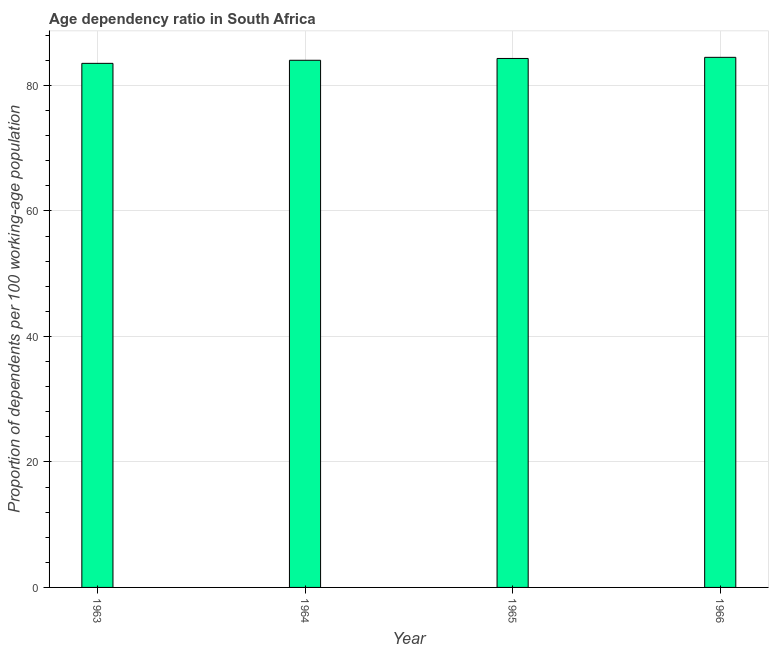Does the graph contain grids?
Provide a short and direct response. Yes. What is the title of the graph?
Ensure brevity in your answer.  Age dependency ratio in South Africa. What is the label or title of the X-axis?
Your response must be concise. Year. What is the label or title of the Y-axis?
Your answer should be very brief. Proportion of dependents per 100 working-age population. What is the age dependency ratio in 1963?
Give a very brief answer. 83.53. Across all years, what is the maximum age dependency ratio?
Provide a succinct answer. 84.49. Across all years, what is the minimum age dependency ratio?
Give a very brief answer. 83.53. In which year was the age dependency ratio maximum?
Provide a short and direct response. 1966. What is the sum of the age dependency ratio?
Offer a very short reply. 336.35. What is the difference between the age dependency ratio in 1964 and 1965?
Make the answer very short. -0.29. What is the average age dependency ratio per year?
Offer a terse response. 84.09. What is the median age dependency ratio?
Give a very brief answer. 84.17. What is the difference between the highest and the second highest age dependency ratio?
Make the answer very short. 0.18. Is the sum of the age dependency ratio in 1964 and 1965 greater than the maximum age dependency ratio across all years?
Your response must be concise. Yes. What is the difference between the highest and the lowest age dependency ratio?
Your answer should be compact. 0.96. In how many years, is the age dependency ratio greater than the average age dependency ratio taken over all years?
Ensure brevity in your answer.  2. How many years are there in the graph?
Give a very brief answer. 4. What is the difference between two consecutive major ticks on the Y-axis?
Provide a succinct answer. 20. Are the values on the major ticks of Y-axis written in scientific E-notation?
Your answer should be very brief. No. What is the Proportion of dependents per 100 working-age population in 1963?
Offer a terse response. 83.53. What is the Proportion of dependents per 100 working-age population of 1964?
Provide a succinct answer. 84.02. What is the Proportion of dependents per 100 working-age population of 1965?
Offer a terse response. 84.31. What is the Proportion of dependents per 100 working-age population in 1966?
Give a very brief answer. 84.49. What is the difference between the Proportion of dependents per 100 working-age population in 1963 and 1964?
Give a very brief answer. -0.49. What is the difference between the Proportion of dependents per 100 working-age population in 1963 and 1965?
Provide a short and direct response. -0.78. What is the difference between the Proportion of dependents per 100 working-age population in 1963 and 1966?
Keep it short and to the point. -0.96. What is the difference between the Proportion of dependents per 100 working-age population in 1964 and 1965?
Provide a succinct answer. -0.29. What is the difference between the Proportion of dependents per 100 working-age population in 1964 and 1966?
Offer a terse response. -0.47. What is the difference between the Proportion of dependents per 100 working-age population in 1965 and 1966?
Provide a short and direct response. -0.18. What is the ratio of the Proportion of dependents per 100 working-age population in 1963 to that in 1965?
Your answer should be very brief. 0.99. What is the ratio of the Proportion of dependents per 100 working-age population in 1963 to that in 1966?
Make the answer very short. 0.99. What is the ratio of the Proportion of dependents per 100 working-age population in 1964 to that in 1966?
Offer a terse response. 0.99. 